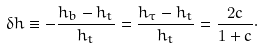Convert formula to latex. <formula><loc_0><loc_0><loc_500><loc_500>\delta h \equiv - \frac { h _ { b } - h _ { t } } { h _ { t } } = \frac { h _ { \tau } - h _ { t } } { h _ { t } } = \frac { 2 c } { 1 + c } \cdot</formula> 